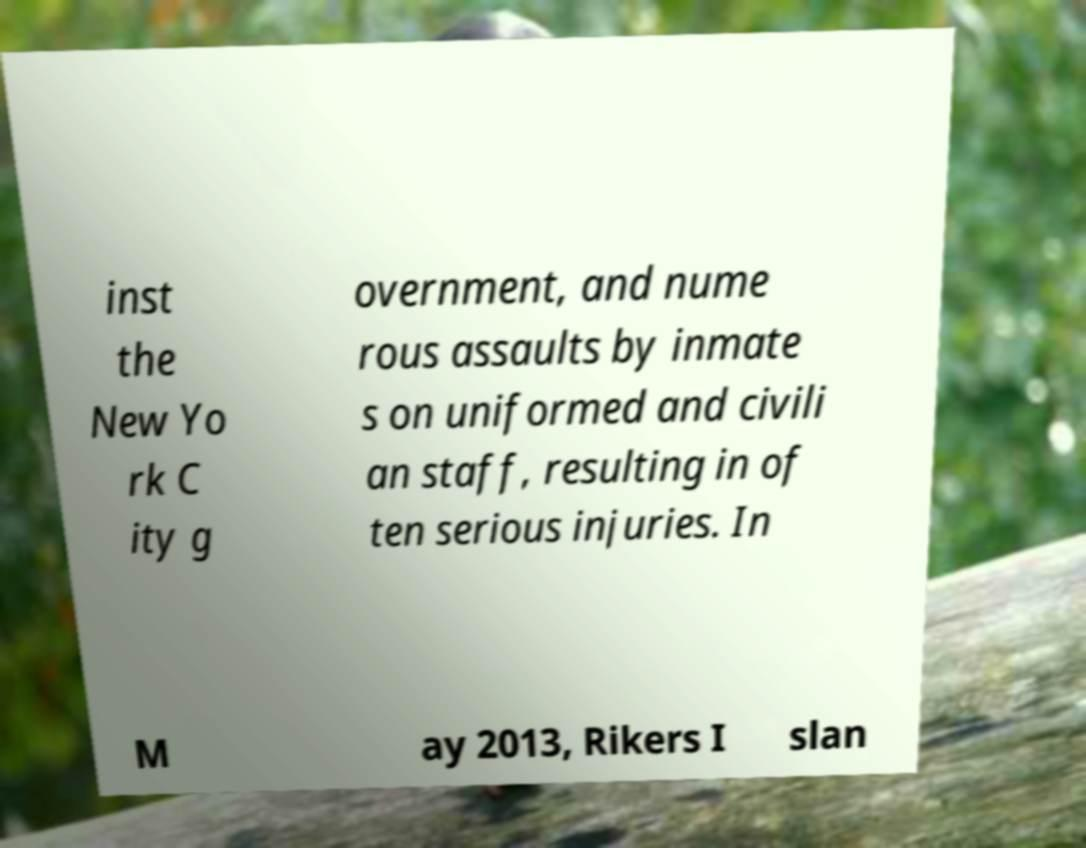Could you extract and type out the text from this image? inst the New Yo rk C ity g overnment, and nume rous assaults by inmate s on uniformed and civili an staff, resulting in of ten serious injuries. In M ay 2013, Rikers I slan 